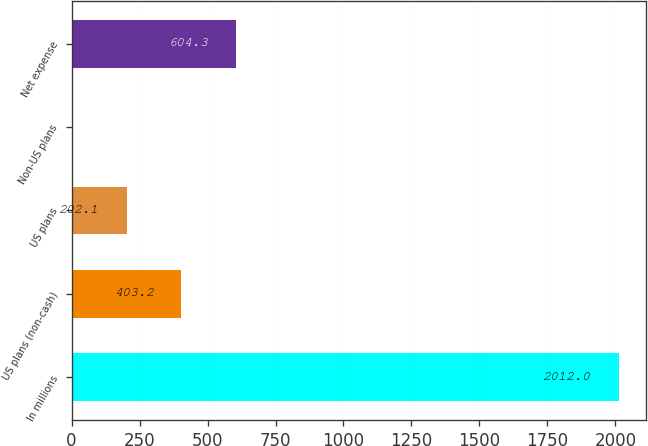Convert chart to OTSL. <chart><loc_0><loc_0><loc_500><loc_500><bar_chart><fcel>In millions<fcel>US plans (non-cash)<fcel>US plans<fcel>Non-US plans<fcel>Net expense<nl><fcel>2012<fcel>403.2<fcel>202.1<fcel>1<fcel>604.3<nl></chart> 